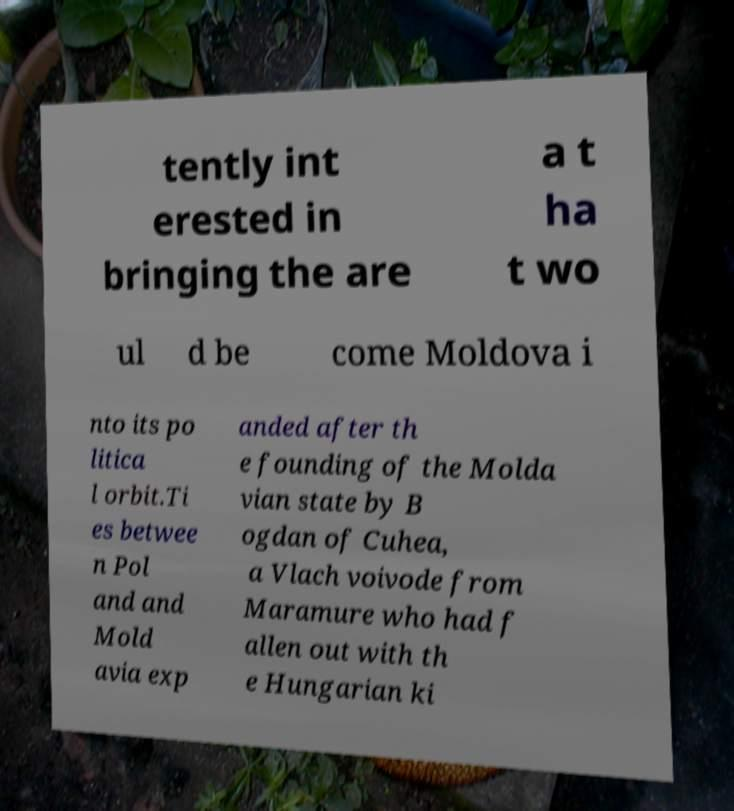Please read and relay the text visible in this image. What does it say? tently int erested in bringing the are a t ha t wo ul d be come Moldova i nto its po litica l orbit.Ti es betwee n Pol and and Mold avia exp anded after th e founding of the Molda vian state by B ogdan of Cuhea, a Vlach voivode from Maramure who had f allen out with th e Hungarian ki 